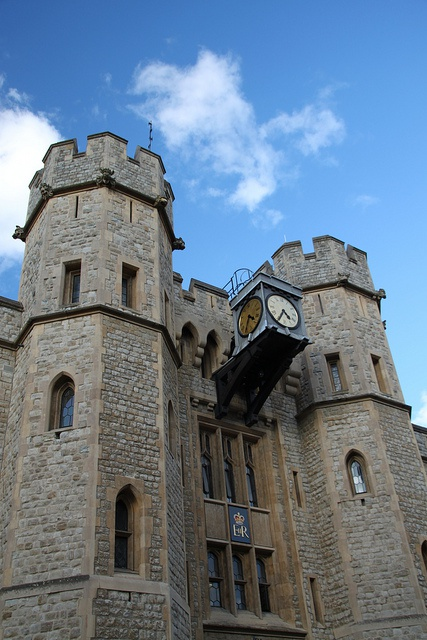Describe the objects in this image and their specific colors. I can see clock in blue, darkgray, black, gray, and lightgray tones and clock in blue, olive, black, and gray tones in this image. 